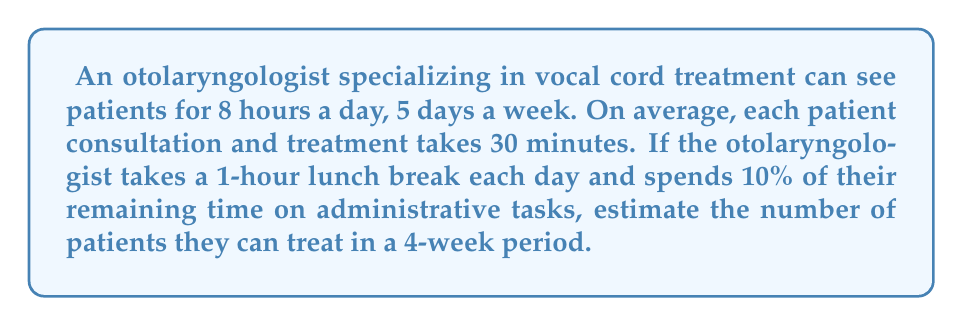Help me with this question. Let's break this down step-by-step:

1) First, calculate the total working hours in a 4-week period:
   $8 \text{ hours/day} \times 5 \text{ days/week} \times 4 \text{ weeks} = 160 \text{ hours}$

2) Subtract lunch breaks:
   $1 \text{ hour/day} \times 5 \text{ days/week} \times 4 \text{ weeks} = 20 \text{ hours}$
   $160 \text{ hours} - 20 \text{ hours} = 140 \text{ hours}$

3) Calculate time spent on administrative tasks:
   $10\% \text{ of } 140 \text{ hours} = 0.1 \times 140 = 14 \text{ hours}$

4) Calculate time available for patient consultations:
   $140 \text{ hours} - 14 \text{ hours} = 126 \text{ hours}$

5) Convert available time to minutes:
   $126 \text{ hours} \times 60 \text{ minutes/hour} = 7560 \text{ minutes}$

6) Calculate number of patients that can be seen:
   $\frac{7560 \text{ minutes}}{30 \text{ minutes/patient}} = 252 \text{ patients}$

Therefore, the otolaryngologist can treat approximately 252 patients in a 4-week period.
Answer: 252 patients 